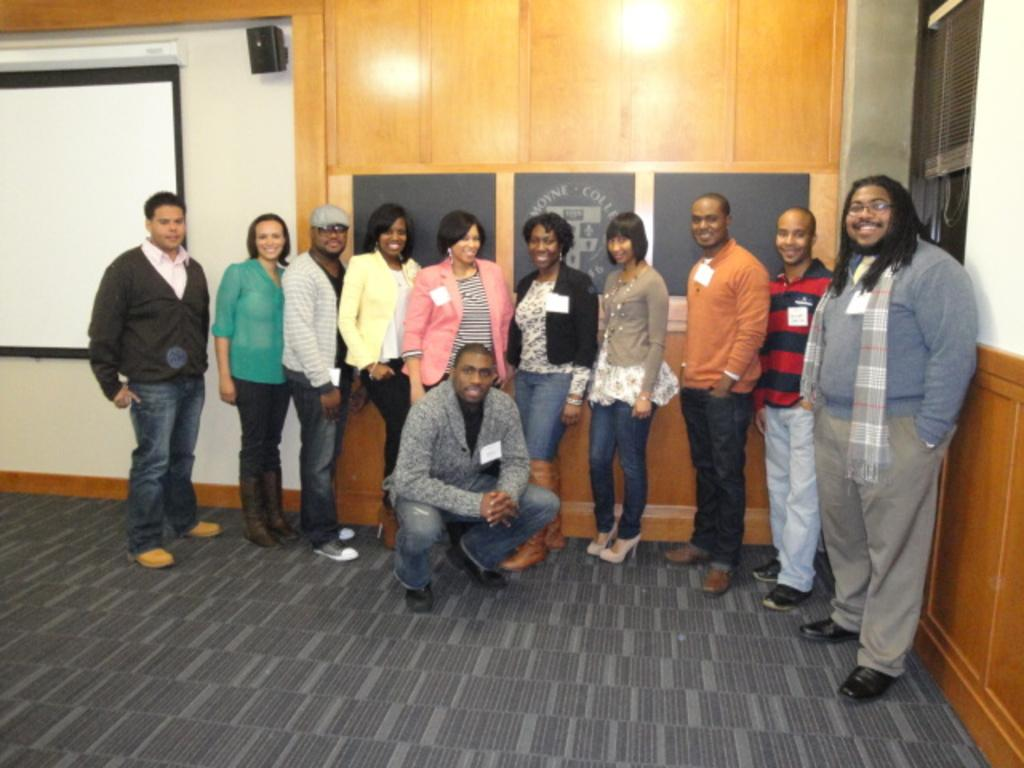What are the people in the image doing? There is a group of people on the floor in the image. What can be seen on the wall in the image? There are boards on a wall in the image. What device is present for displaying information or media? There is a display screen in the image. What is used for amplifying sound in the image? There is a speaker box in the image. What type of window covering is visible in the image? There is a window blind in the image. What type of chalk is being used by the people on the floor? There is no chalk present in the image; the people are not using any chalk. What time of day is it in the image? The time of day cannot be determined from the image alone, as there are no specific time-related details provided. 